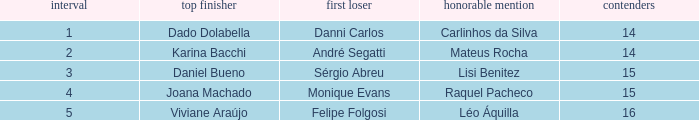How many contestants were there when the runner-up was Monique Evans? 15.0. Give me the full table as a dictionary. {'header': ['interval', 'top finisher', 'first loser', 'honorable mention', 'contenders'], 'rows': [['1', 'Dado Dolabella', 'Danni Carlos', 'Carlinhos da Silva', '14'], ['2', 'Karina Bacchi', 'André Segatti', 'Mateus Rocha', '14'], ['3', 'Daniel Bueno', 'Sérgio Abreu', 'Lisi Benitez', '15'], ['4', 'Joana Machado', 'Monique Evans', 'Raquel Pacheco', '15'], ['5', 'Viviane Araújo', 'Felipe Folgosi', 'Léo Áquilla', '16']]} 